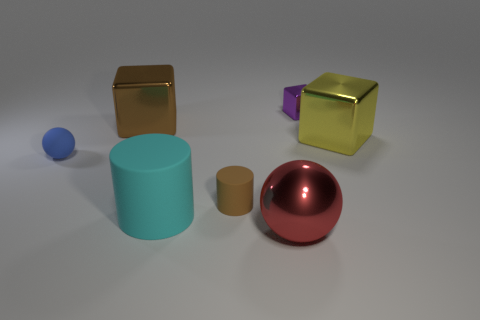Add 1 tiny purple things. How many objects exist? 8 Subtract all cylinders. How many objects are left? 5 Subtract all cyan matte objects. Subtract all big rubber cylinders. How many objects are left? 5 Add 2 large metallic things. How many large metallic things are left? 5 Add 1 small brown matte objects. How many small brown matte objects exist? 2 Subtract 0 gray blocks. How many objects are left? 7 